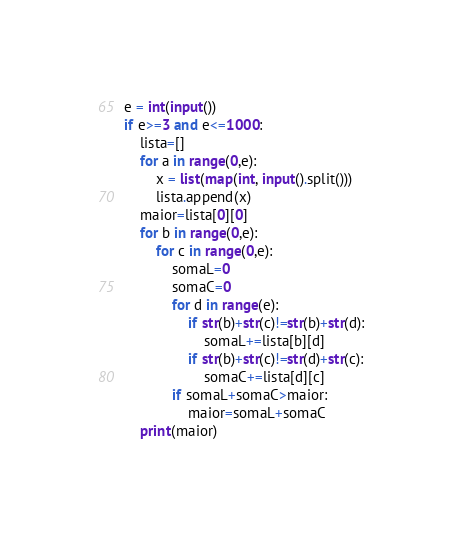<code> <loc_0><loc_0><loc_500><loc_500><_Python_>e = int(input())
if e>=3 and e<=1000:
    lista=[]
    for a in range(0,e):
        x = list(map(int, input().split()))
        lista.append(x)
    maior=lista[0][0]
    for b in range(0,e):
        for c in range(0,e):
            somaL=0
            somaC=0
            for d in range(e):
                if str(b)+str(c)!=str(b)+str(d):
                    somaL+=lista[b][d]
                if str(b)+str(c)!=str(d)+str(c):
                    somaC+=lista[d][c]
            if somaL+somaC>maior:
                maior=somaL+somaC
    print(maior)
</code> 